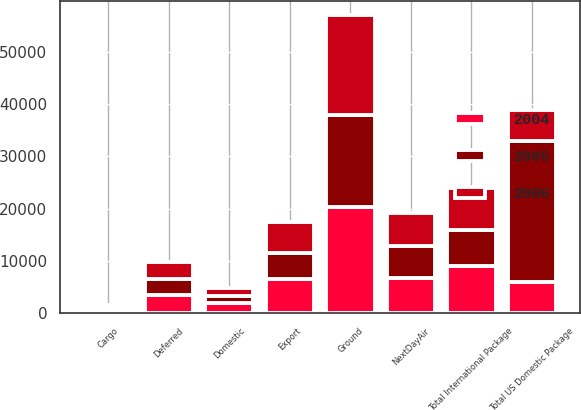Convert chart to OTSL. <chart><loc_0><loc_0><loc_500><loc_500><stacked_bar_chart><ecel><fcel>NextDayAir<fcel>Deferred<fcel>Ground<fcel>Total US Domestic Package<fcel>Domestic<fcel>Export<fcel>Cargo<fcel>Total International Package<nl><fcel>2004<fcel>6778<fcel>3424<fcel>20254<fcel>5970<fcel>1950<fcel>6554<fcel>585<fcel>9089<nl><fcel>2006<fcel>6381<fcel>3258<fcel>18971<fcel>5970<fcel>1588<fcel>5856<fcel>533<fcel>7977<nl><fcel>2005<fcel>6084<fcel>3193<fcel>17683<fcel>26960<fcel>1346<fcel>4991<fcel>472<fcel>6809<nl></chart> 